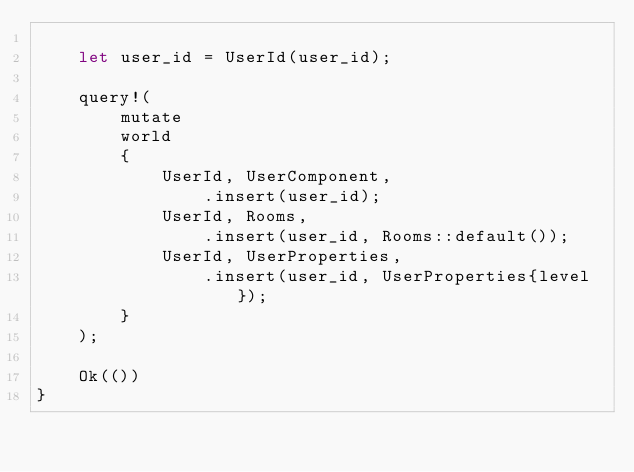Convert code to text. <code><loc_0><loc_0><loc_500><loc_500><_Rust_>
    let user_id = UserId(user_id);

    query!(
        mutate
        world
        {
            UserId, UserComponent,
                .insert(user_id);
            UserId, Rooms,
                .insert(user_id, Rooms::default());
            UserId, UserProperties,
                .insert(user_id, UserProperties{level});
        }
    );

    Ok(())
}
</code> 